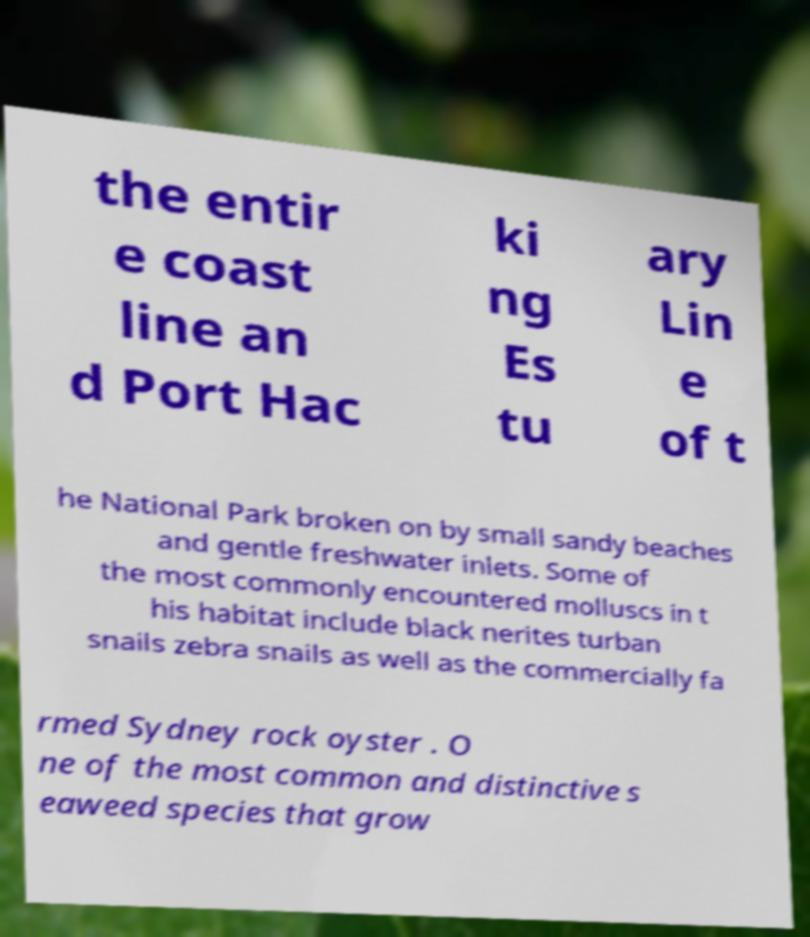Could you assist in decoding the text presented in this image and type it out clearly? the entir e coast line an d Port Hac ki ng Es tu ary Lin e of t he National Park broken on by small sandy beaches and gentle freshwater inlets. Some of the most commonly encountered molluscs in t his habitat include black nerites turban snails zebra snails as well as the commercially fa rmed Sydney rock oyster . O ne of the most common and distinctive s eaweed species that grow 